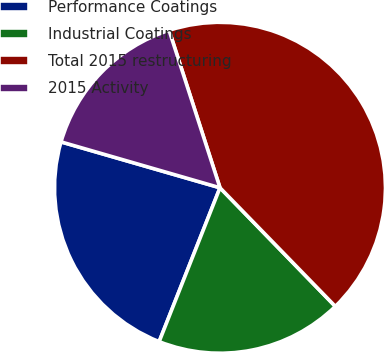Convert chart to OTSL. <chart><loc_0><loc_0><loc_500><loc_500><pie_chart><fcel>Performance Coatings<fcel>Industrial Coatings<fcel>Total 2015 restructuring<fcel>2015 Activity<nl><fcel>23.48%<fcel>18.27%<fcel>42.7%<fcel>15.55%<nl></chart> 